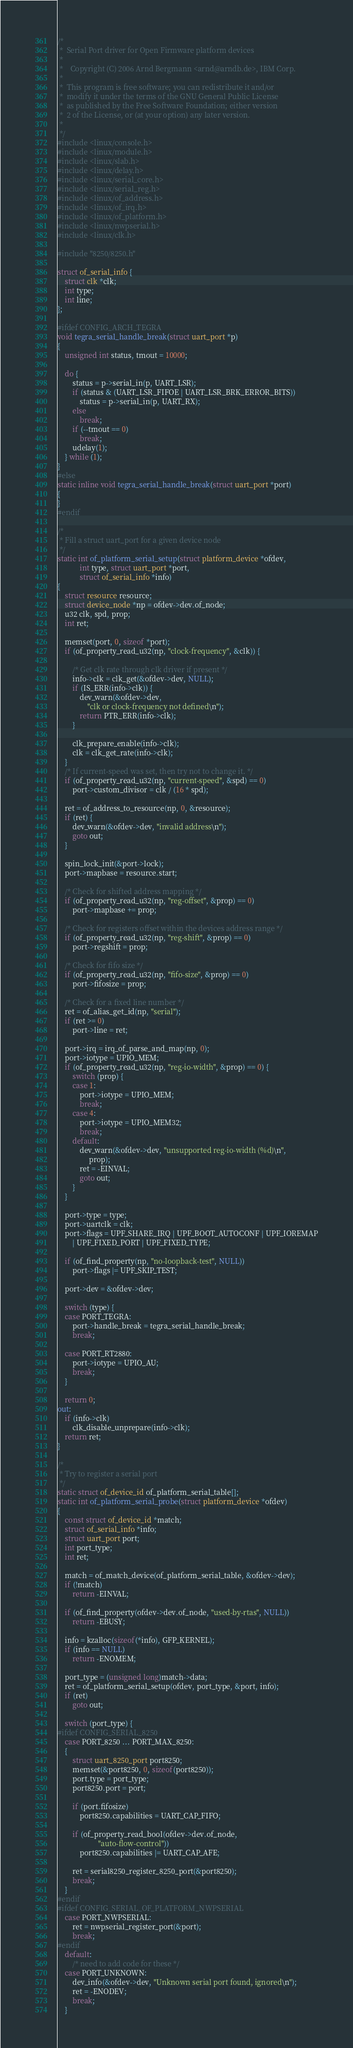Convert code to text. <code><loc_0><loc_0><loc_500><loc_500><_C_>/*
 *  Serial Port driver for Open Firmware platform devices
 *
 *    Copyright (C) 2006 Arnd Bergmann <arnd@arndb.de>, IBM Corp.
 *
 *  This program is free software; you can redistribute it and/or
 *  modify it under the terms of the GNU General Public License
 *  as published by the Free Software Foundation; either version
 *  2 of the License, or (at your option) any later version.
 *
 */
#include <linux/console.h>
#include <linux/module.h>
#include <linux/slab.h>
#include <linux/delay.h>
#include <linux/serial_core.h>
#include <linux/serial_reg.h>
#include <linux/of_address.h>
#include <linux/of_irq.h>
#include <linux/of_platform.h>
#include <linux/nwpserial.h>
#include <linux/clk.h>

#include "8250/8250.h"

struct of_serial_info {
	struct clk *clk;
	int type;
	int line;
};

#ifdef CONFIG_ARCH_TEGRA
void tegra_serial_handle_break(struct uart_port *p)
{
	unsigned int status, tmout = 10000;

	do {
		status = p->serial_in(p, UART_LSR);
		if (status & (UART_LSR_FIFOE | UART_LSR_BRK_ERROR_BITS))
			status = p->serial_in(p, UART_RX);
		else
			break;
		if (--tmout == 0)
			break;
		udelay(1);
	} while (1);
}
#else
static inline void tegra_serial_handle_break(struct uart_port *port)
{
}
#endif

/*
 * Fill a struct uart_port for a given device node
 */
static int of_platform_serial_setup(struct platform_device *ofdev,
			int type, struct uart_port *port,
			struct of_serial_info *info)
{
	struct resource resource;
	struct device_node *np = ofdev->dev.of_node;
	u32 clk, spd, prop;
	int ret;

	memset(port, 0, sizeof *port);
	if (of_property_read_u32(np, "clock-frequency", &clk)) {

		/* Get clk rate through clk driver if present */
		info->clk = clk_get(&ofdev->dev, NULL);
		if (IS_ERR(info->clk)) {
			dev_warn(&ofdev->dev,
				"clk or clock-frequency not defined\n");
			return PTR_ERR(info->clk);
		}

		clk_prepare_enable(info->clk);
		clk = clk_get_rate(info->clk);
	}
	/* If current-speed was set, then try not to change it. */
	if (of_property_read_u32(np, "current-speed", &spd) == 0)
		port->custom_divisor = clk / (16 * spd);

	ret = of_address_to_resource(np, 0, &resource);
	if (ret) {
		dev_warn(&ofdev->dev, "invalid address\n");
		goto out;
	}

	spin_lock_init(&port->lock);
	port->mapbase = resource.start;

	/* Check for shifted address mapping */
	if (of_property_read_u32(np, "reg-offset", &prop) == 0)
		port->mapbase += prop;

	/* Check for registers offset within the devices address range */
	if (of_property_read_u32(np, "reg-shift", &prop) == 0)
		port->regshift = prop;

	/* Check for fifo size */
	if (of_property_read_u32(np, "fifo-size", &prop) == 0)
		port->fifosize = prop;

	/* Check for a fixed line number */
	ret = of_alias_get_id(np, "serial");
	if (ret >= 0)
		port->line = ret;

	port->irq = irq_of_parse_and_map(np, 0);
	port->iotype = UPIO_MEM;
	if (of_property_read_u32(np, "reg-io-width", &prop) == 0) {
		switch (prop) {
		case 1:
			port->iotype = UPIO_MEM;
			break;
		case 4:
			port->iotype = UPIO_MEM32;
			break;
		default:
			dev_warn(&ofdev->dev, "unsupported reg-io-width (%d)\n",
				 prop);
			ret = -EINVAL;
			goto out;
		}
	}

	port->type = type;
	port->uartclk = clk;
	port->flags = UPF_SHARE_IRQ | UPF_BOOT_AUTOCONF | UPF_IOREMAP
		| UPF_FIXED_PORT | UPF_FIXED_TYPE;

	if (of_find_property(np, "no-loopback-test", NULL))
		port->flags |= UPF_SKIP_TEST;

	port->dev = &ofdev->dev;

	switch (type) {
	case PORT_TEGRA:
		port->handle_break = tegra_serial_handle_break;
		break;

	case PORT_RT2880:
		port->iotype = UPIO_AU;
		break;
	}

	return 0;
out:
	if (info->clk)
		clk_disable_unprepare(info->clk);
	return ret;
}

/*
 * Try to register a serial port
 */
static struct of_device_id of_platform_serial_table[];
static int of_platform_serial_probe(struct platform_device *ofdev)
{
	const struct of_device_id *match;
	struct of_serial_info *info;
	struct uart_port port;
	int port_type;
	int ret;

	match = of_match_device(of_platform_serial_table, &ofdev->dev);
	if (!match)
		return -EINVAL;

	if (of_find_property(ofdev->dev.of_node, "used-by-rtas", NULL))
		return -EBUSY;

	info = kzalloc(sizeof(*info), GFP_KERNEL);
	if (info == NULL)
		return -ENOMEM;

	port_type = (unsigned long)match->data;
	ret = of_platform_serial_setup(ofdev, port_type, &port, info);
	if (ret)
		goto out;

	switch (port_type) {
#ifdef CONFIG_SERIAL_8250
	case PORT_8250 ... PORT_MAX_8250:
	{
		struct uart_8250_port port8250;
		memset(&port8250, 0, sizeof(port8250));
		port.type = port_type;
		port8250.port = port;

		if (port.fifosize)
			port8250.capabilities = UART_CAP_FIFO;

		if (of_property_read_bool(ofdev->dev.of_node,
					  "auto-flow-control"))
			port8250.capabilities |= UART_CAP_AFE;

		ret = serial8250_register_8250_port(&port8250);
		break;
	}
#endif
#ifdef CONFIG_SERIAL_OF_PLATFORM_NWPSERIAL
	case PORT_NWPSERIAL:
		ret = nwpserial_register_port(&port);
		break;
#endif
	default:
		/* need to add code for these */
	case PORT_UNKNOWN:
		dev_info(&ofdev->dev, "Unknown serial port found, ignored\n");
		ret = -ENODEV;
		break;
	}</code> 